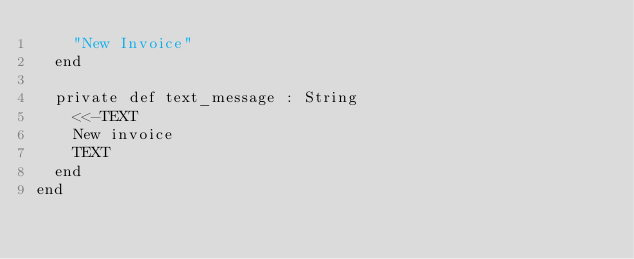Convert code to text. <code><loc_0><loc_0><loc_500><loc_500><_Crystal_>    "New Invoice"
  end

  private def text_message : String
    <<-TEXT
    New invoice
    TEXT
  end
end
</code> 